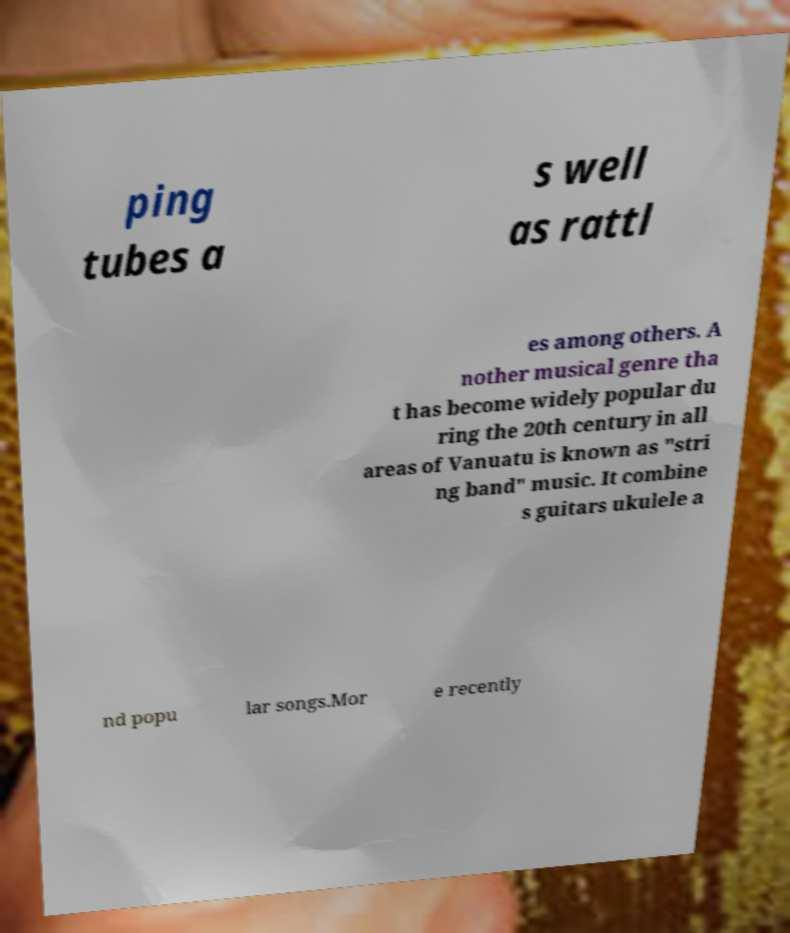Could you assist in decoding the text presented in this image and type it out clearly? ping tubes a s well as rattl es among others. A nother musical genre tha t has become widely popular du ring the 20th century in all areas of Vanuatu is known as "stri ng band" music. It combine s guitars ukulele a nd popu lar songs.Mor e recently 